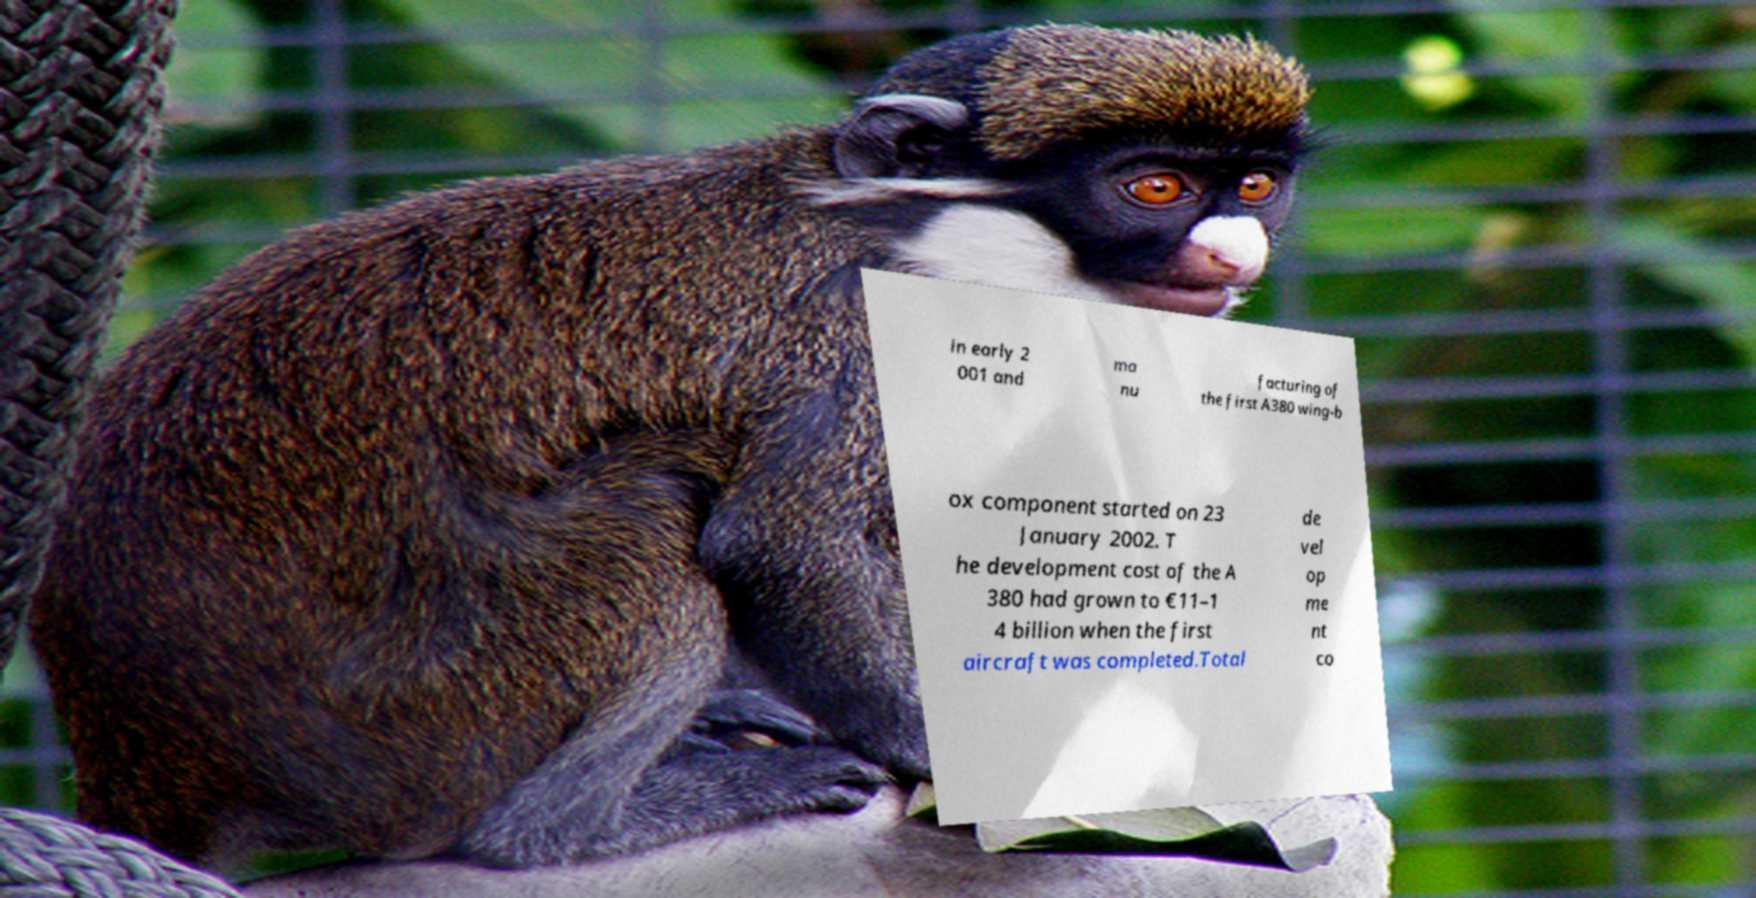Please identify and transcribe the text found in this image. in early 2 001 and ma nu facturing of the first A380 wing-b ox component started on 23 January 2002. T he development cost of the A 380 had grown to €11–1 4 billion when the first aircraft was completed.Total de vel op me nt co 